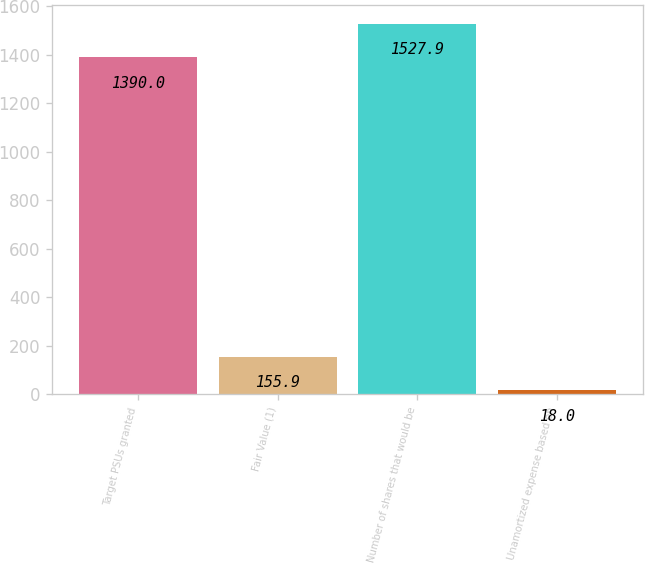<chart> <loc_0><loc_0><loc_500><loc_500><bar_chart><fcel>Target PSUs granted<fcel>Fair Value (1)<fcel>Number of shares that would be<fcel>Unamortized expense based on<nl><fcel>1390<fcel>155.9<fcel>1527.9<fcel>18<nl></chart> 